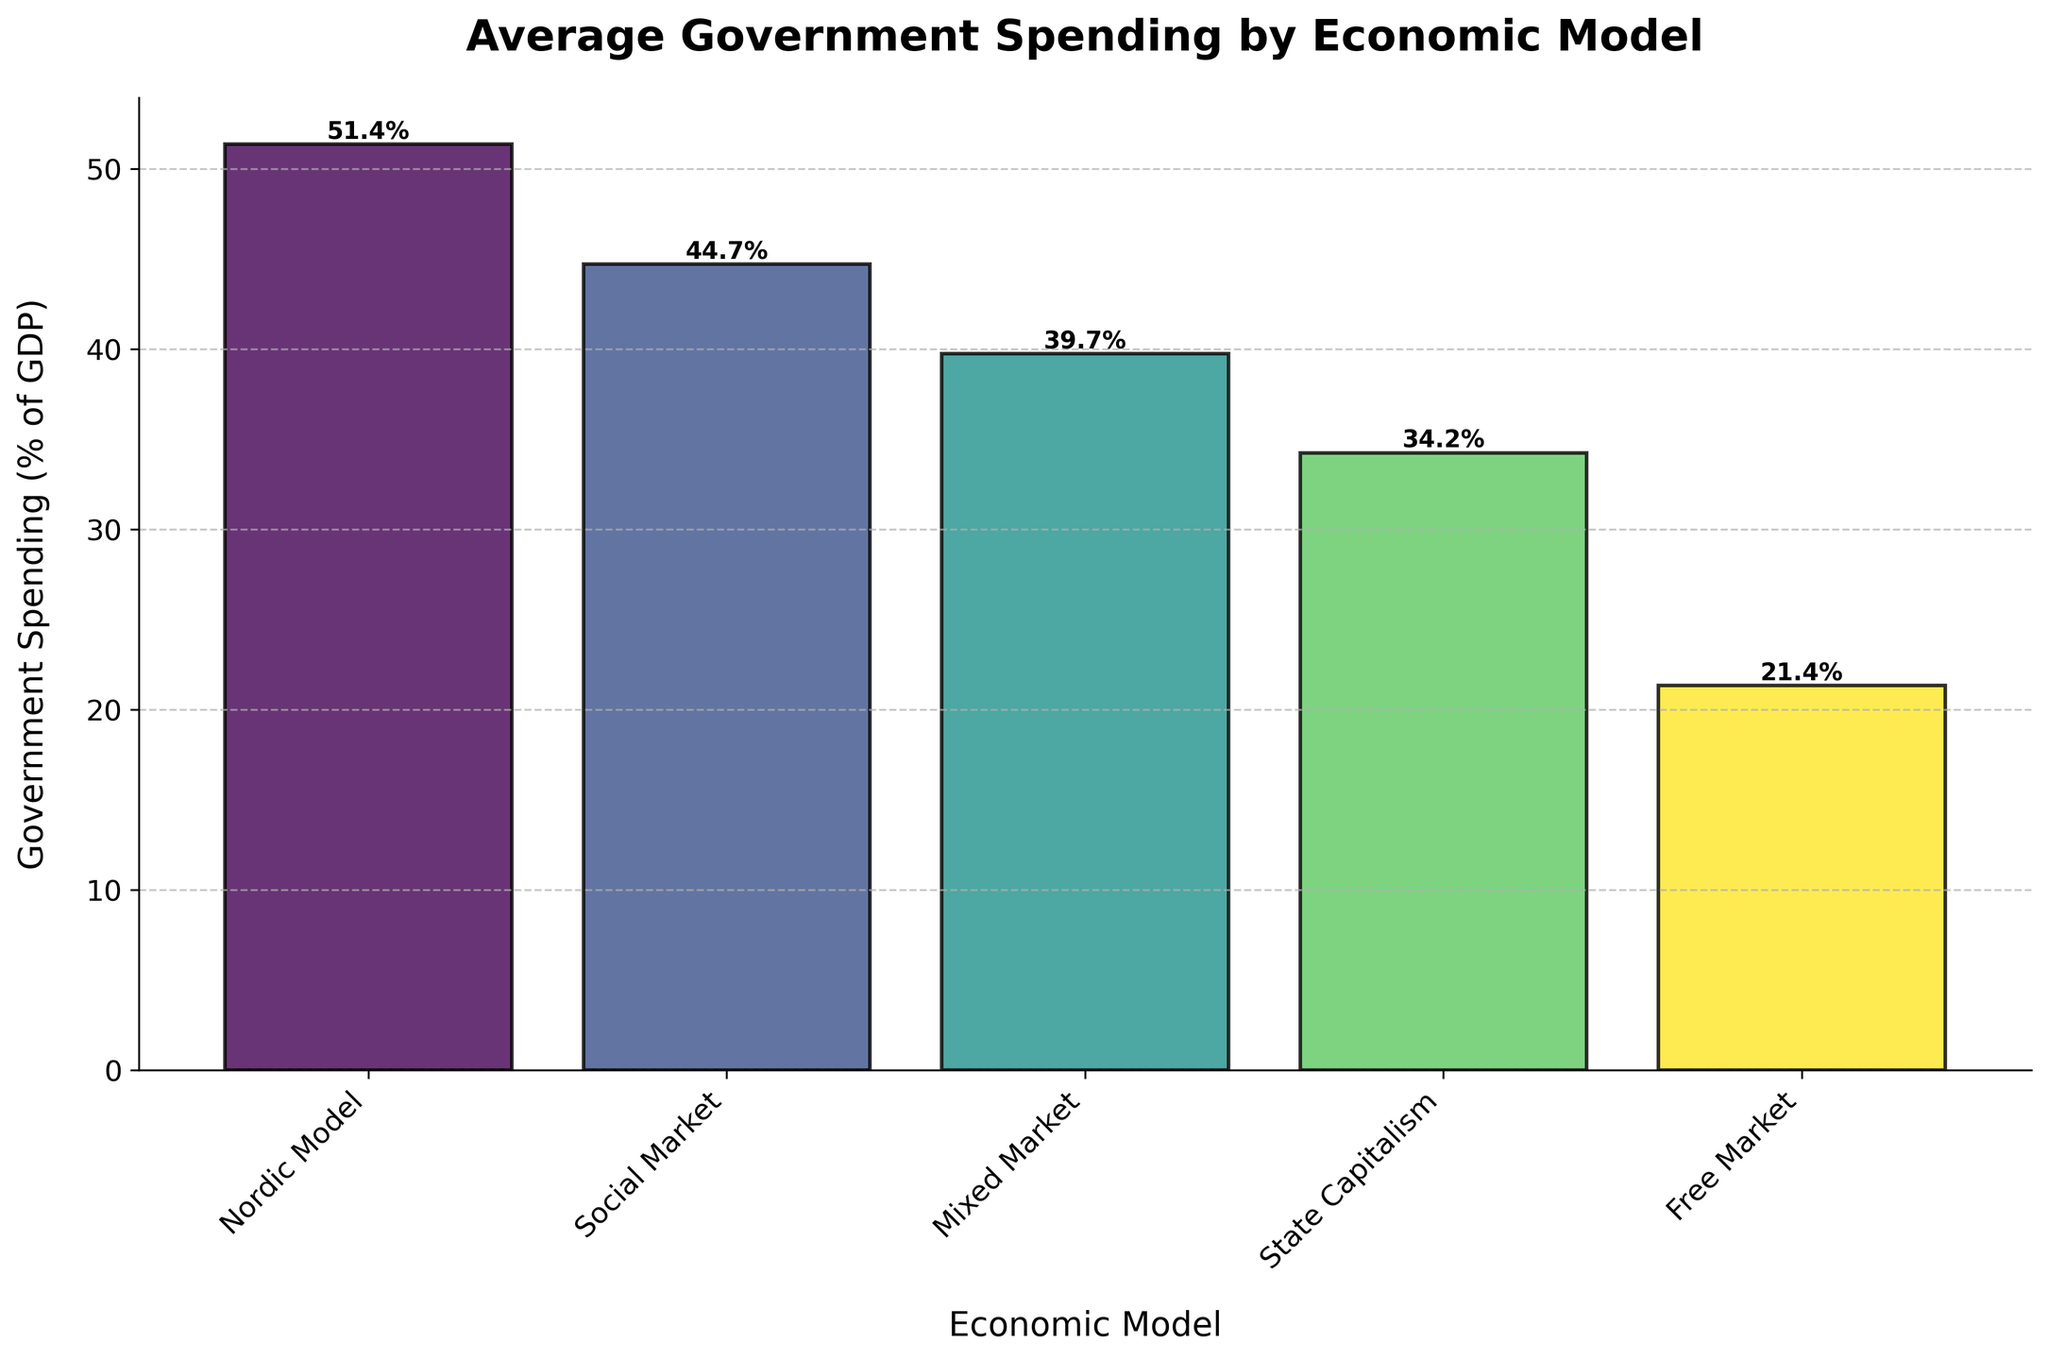What is the average government spending as a percentage of GDP for the Mixed Market economic model? To calculate the average, sum up the government spending percentages for all countries under the Mixed Market model and divide by the number of those countries. The sum is 38.9 + 39.2 + 41.0 + 55.6 + 41.1 + 36.2 + 23.0 + 37.1 + 27.1 + 42.1 + 48.8 + 41.5 + 39.6 + 24.8 + 45.4 + 47.8 + 46.5 = 637.7. There are 17 countries, so the average is 637.7 / 17 = 37.5%.
Answer: 37.5% Which economic model has the highest average government spending as a percentage of GDP? By looking at the height of the bars, the Nordic Model has the tallest bar, indicating the highest average government spending as a percentage of GDP.
Answer: Nordic Model Which economic model has the lowest average government spending as a percentage of GDP, and what is the value? By examining the heights of the bars, the Free Market model has the shortest bar, indicating the lowest average government spending as a percentage of GDP. The value can be read directly from the bar label indicating approximately 21.4%.
Answer: Free Market, 21.4% Is the average government spending of the Social Market model greater than that of the State Capitalism model? We compare the heights of the bars for the Social Market and State Capitalism models. The Social Market bar is higher, indicating it has a greater average government spending percentage.
Answer: Yes What is the difference in the average government spending between the Nordic Model and Mixed Market model? From the figure, identify the average percentages: Nordic Model (51.9%) and Mixed Market (37.5%). Then, subtract the Mixed Market value from the Nordic Model value: 51.9% - 37.5% = 14.4%.
Answer: 14.4% Which economic model's bar is visually closest in height to that of the Social Market model? By looking at the height of the bars, the Mixed Market model's bar appears to be closest in height to the Social Market model.
Answer: Mixed Market If the average government spending for the State Capitalism model increases by 3%, how would it compare to the Social Market model? The current average for State Capitalism is 34.3%. Increasing it by 3% gives 34.3% + 3% = 37.3%. The Social Market average is 44.2%. Therefore, 37.3% for State Capitalism is still less than 44.2% for Social Market.
Answer: Less What is the range of average government spending percentages across all economic models? To find the range, subtract the minimum value (Free Market: 21.4%) from the maximum value (Nordic Model: 51.9%): 51.9% - 21.4% = 30.5%.
Answer: 30.5% How many more percent does the highest spending model spend compared to the lowest? The highest spending model is the Nordic Model with 51.9% and the lowest is the Free Market with 21.4%. The difference is 51.9% - 21.4% = 30.5%.
Answer: 30.5% Does any economic model have an average government spending percentage exactly equal to 40%? By reading the values on the bars, none of the averages of any economic models are exactly equal to 40%.
Answer: No 